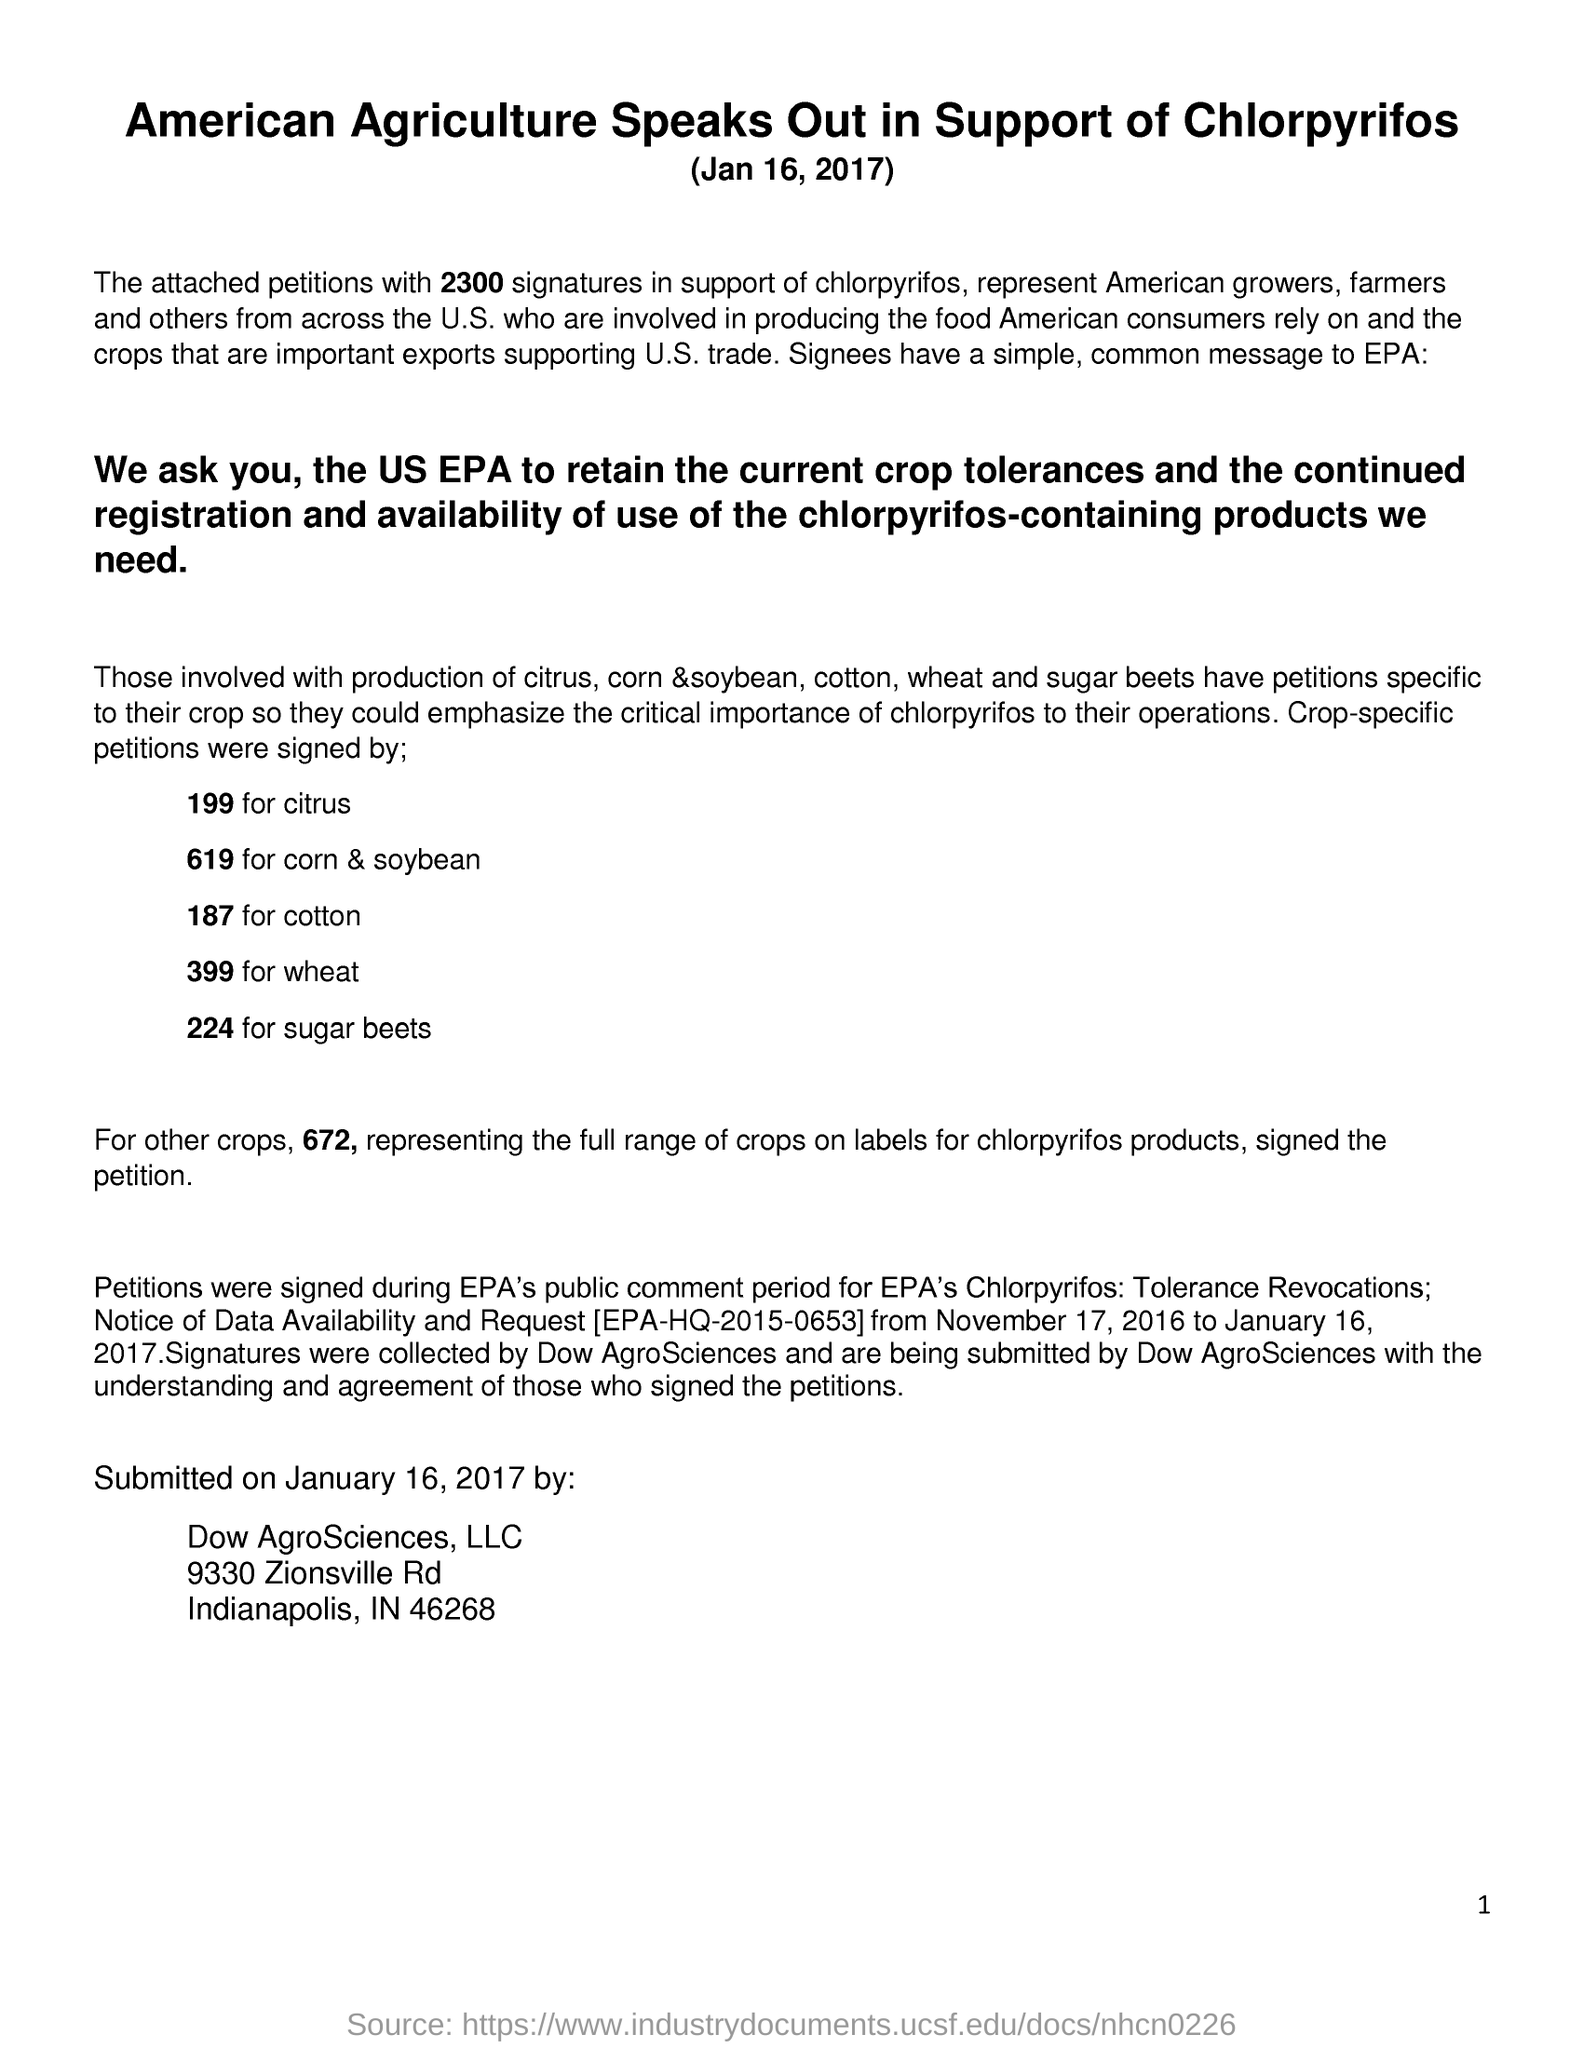224 represents which crop?
Provide a succinct answer. Sugar beets. Citrus is represented by which number?
Make the answer very short. 199. What is the title of the document?
Your response must be concise. Amercian Agriculture Speaks Out in Support of Chlorpyrifos (Jan 16, 2017). 